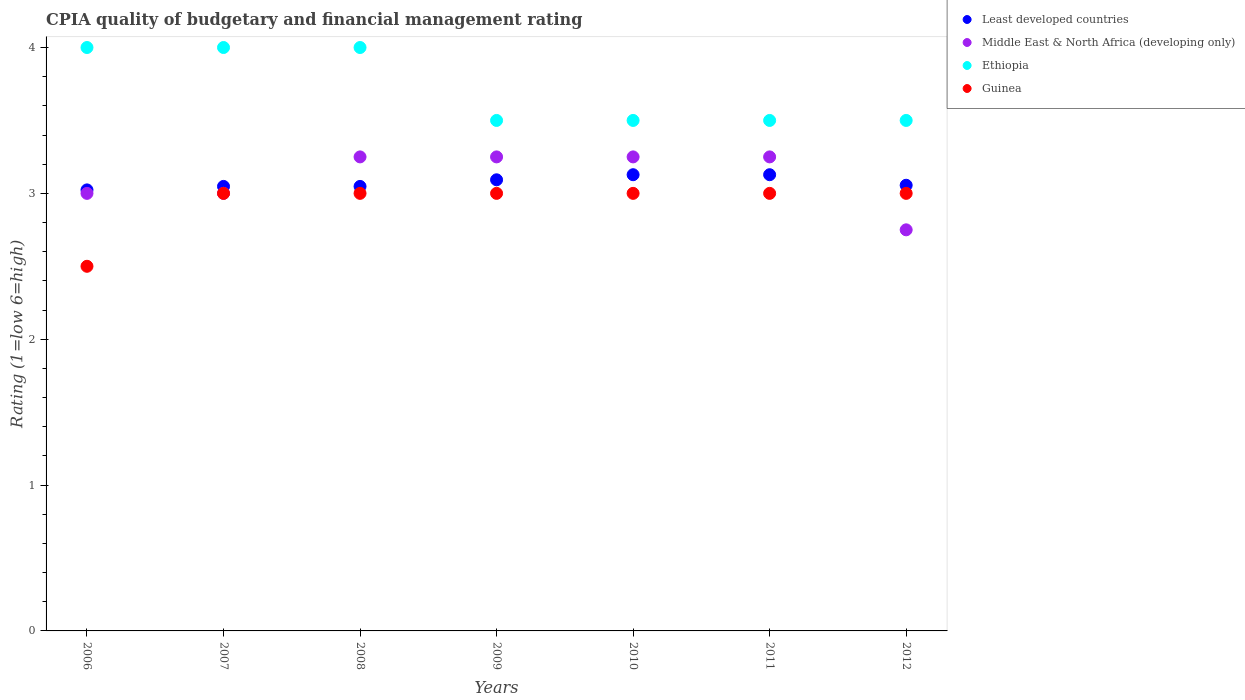Across all years, what is the maximum CPIA rating in Guinea?
Offer a terse response. 3. Across all years, what is the minimum CPIA rating in Middle East & North Africa (developing only)?
Offer a very short reply. 2.75. In which year was the CPIA rating in Ethiopia maximum?
Your answer should be compact. 2006. In which year was the CPIA rating in Guinea minimum?
Provide a succinct answer. 2006. What is the total CPIA rating in Least developed countries in the graph?
Provide a short and direct response. 21.52. What is the difference between the CPIA rating in Least developed countries in 2011 and the CPIA rating in Guinea in 2008?
Offer a terse response. 0.13. What is the average CPIA rating in Least developed countries per year?
Your response must be concise. 3.07. What is the ratio of the CPIA rating in Least developed countries in 2007 to that in 2010?
Offer a terse response. 0.97. Is the CPIA rating in Least developed countries in 2009 less than that in 2012?
Give a very brief answer. No. Is the difference between the CPIA rating in Ethiopia in 2006 and 2009 greater than the difference between the CPIA rating in Guinea in 2006 and 2009?
Give a very brief answer. Yes. What is the difference between the highest and the lowest CPIA rating in Guinea?
Ensure brevity in your answer.  0.5. Is it the case that in every year, the sum of the CPIA rating in Least developed countries and CPIA rating in Ethiopia  is greater than the sum of CPIA rating in Middle East & North Africa (developing only) and CPIA rating in Guinea?
Ensure brevity in your answer.  Yes. Is it the case that in every year, the sum of the CPIA rating in Guinea and CPIA rating in Ethiopia  is greater than the CPIA rating in Least developed countries?
Give a very brief answer. Yes. Does the CPIA rating in Guinea monotonically increase over the years?
Offer a very short reply. No. How many dotlines are there?
Your answer should be compact. 4. How many years are there in the graph?
Ensure brevity in your answer.  7. Are the values on the major ticks of Y-axis written in scientific E-notation?
Provide a succinct answer. No. Does the graph contain any zero values?
Provide a succinct answer. No. Does the graph contain grids?
Ensure brevity in your answer.  No. How are the legend labels stacked?
Offer a terse response. Vertical. What is the title of the graph?
Your answer should be very brief. CPIA quality of budgetary and financial management rating. What is the label or title of the X-axis?
Provide a succinct answer. Years. What is the Rating (1=low 6=high) of Least developed countries in 2006?
Ensure brevity in your answer.  3.02. What is the Rating (1=low 6=high) of Middle East & North Africa (developing only) in 2006?
Keep it short and to the point. 3. What is the Rating (1=low 6=high) of Least developed countries in 2007?
Your response must be concise. 3.05. What is the Rating (1=low 6=high) in Middle East & North Africa (developing only) in 2007?
Your response must be concise. 3. What is the Rating (1=low 6=high) of Ethiopia in 2007?
Give a very brief answer. 4. What is the Rating (1=low 6=high) in Guinea in 2007?
Your answer should be very brief. 3. What is the Rating (1=low 6=high) in Least developed countries in 2008?
Give a very brief answer. 3.05. What is the Rating (1=low 6=high) in Ethiopia in 2008?
Give a very brief answer. 4. What is the Rating (1=low 6=high) of Guinea in 2008?
Provide a short and direct response. 3. What is the Rating (1=low 6=high) of Least developed countries in 2009?
Your answer should be compact. 3.09. What is the Rating (1=low 6=high) in Middle East & North Africa (developing only) in 2009?
Offer a terse response. 3.25. What is the Rating (1=low 6=high) in Ethiopia in 2009?
Make the answer very short. 3.5. What is the Rating (1=low 6=high) of Guinea in 2009?
Give a very brief answer. 3. What is the Rating (1=low 6=high) in Least developed countries in 2010?
Give a very brief answer. 3.13. What is the Rating (1=low 6=high) of Ethiopia in 2010?
Provide a short and direct response. 3.5. What is the Rating (1=low 6=high) in Guinea in 2010?
Offer a terse response. 3. What is the Rating (1=low 6=high) in Least developed countries in 2011?
Make the answer very short. 3.13. What is the Rating (1=low 6=high) of Middle East & North Africa (developing only) in 2011?
Make the answer very short. 3.25. What is the Rating (1=low 6=high) of Least developed countries in 2012?
Your answer should be compact. 3.06. What is the Rating (1=low 6=high) of Middle East & North Africa (developing only) in 2012?
Offer a very short reply. 2.75. What is the Rating (1=low 6=high) in Guinea in 2012?
Your answer should be very brief. 3. Across all years, what is the maximum Rating (1=low 6=high) of Least developed countries?
Provide a succinct answer. 3.13. Across all years, what is the maximum Rating (1=low 6=high) in Ethiopia?
Provide a succinct answer. 4. Across all years, what is the maximum Rating (1=low 6=high) in Guinea?
Offer a terse response. 3. Across all years, what is the minimum Rating (1=low 6=high) of Least developed countries?
Your response must be concise. 3.02. Across all years, what is the minimum Rating (1=low 6=high) in Middle East & North Africa (developing only)?
Provide a succinct answer. 2.75. Across all years, what is the minimum Rating (1=low 6=high) of Guinea?
Provide a succinct answer. 2.5. What is the total Rating (1=low 6=high) of Least developed countries in the graph?
Offer a terse response. 21.52. What is the total Rating (1=low 6=high) of Middle East & North Africa (developing only) in the graph?
Offer a terse response. 21.75. What is the total Rating (1=low 6=high) in Guinea in the graph?
Ensure brevity in your answer.  20.5. What is the difference between the Rating (1=low 6=high) in Least developed countries in 2006 and that in 2007?
Your answer should be compact. -0.02. What is the difference between the Rating (1=low 6=high) in Guinea in 2006 and that in 2007?
Your answer should be very brief. -0.5. What is the difference between the Rating (1=low 6=high) in Least developed countries in 2006 and that in 2008?
Your answer should be very brief. -0.02. What is the difference between the Rating (1=low 6=high) of Middle East & North Africa (developing only) in 2006 and that in 2008?
Make the answer very short. -0.25. What is the difference between the Rating (1=low 6=high) in Least developed countries in 2006 and that in 2009?
Offer a terse response. -0.07. What is the difference between the Rating (1=low 6=high) in Ethiopia in 2006 and that in 2009?
Ensure brevity in your answer.  0.5. What is the difference between the Rating (1=low 6=high) of Least developed countries in 2006 and that in 2010?
Your answer should be compact. -0.1. What is the difference between the Rating (1=low 6=high) of Ethiopia in 2006 and that in 2010?
Make the answer very short. 0.5. What is the difference between the Rating (1=low 6=high) of Least developed countries in 2006 and that in 2011?
Provide a succinct answer. -0.1. What is the difference between the Rating (1=low 6=high) of Middle East & North Africa (developing only) in 2006 and that in 2011?
Ensure brevity in your answer.  -0.25. What is the difference between the Rating (1=low 6=high) of Ethiopia in 2006 and that in 2011?
Provide a succinct answer. 0.5. What is the difference between the Rating (1=low 6=high) of Guinea in 2006 and that in 2011?
Ensure brevity in your answer.  -0.5. What is the difference between the Rating (1=low 6=high) of Least developed countries in 2006 and that in 2012?
Offer a terse response. -0.03. What is the difference between the Rating (1=low 6=high) of Ethiopia in 2006 and that in 2012?
Offer a terse response. 0.5. What is the difference between the Rating (1=low 6=high) in Guinea in 2006 and that in 2012?
Your response must be concise. -0.5. What is the difference between the Rating (1=low 6=high) of Least developed countries in 2007 and that in 2008?
Provide a short and direct response. 0. What is the difference between the Rating (1=low 6=high) in Least developed countries in 2007 and that in 2009?
Keep it short and to the point. -0.05. What is the difference between the Rating (1=low 6=high) of Ethiopia in 2007 and that in 2009?
Make the answer very short. 0.5. What is the difference between the Rating (1=low 6=high) in Guinea in 2007 and that in 2009?
Your answer should be very brief. 0. What is the difference between the Rating (1=low 6=high) in Least developed countries in 2007 and that in 2010?
Offer a terse response. -0.08. What is the difference between the Rating (1=low 6=high) in Middle East & North Africa (developing only) in 2007 and that in 2010?
Your answer should be very brief. -0.25. What is the difference between the Rating (1=low 6=high) of Least developed countries in 2007 and that in 2011?
Your answer should be very brief. -0.08. What is the difference between the Rating (1=low 6=high) in Middle East & North Africa (developing only) in 2007 and that in 2011?
Provide a short and direct response. -0.25. What is the difference between the Rating (1=low 6=high) in Ethiopia in 2007 and that in 2011?
Provide a short and direct response. 0.5. What is the difference between the Rating (1=low 6=high) in Least developed countries in 2007 and that in 2012?
Your answer should be very brief. -0.01. What is the difference between the Rating (1=low 6=high) of Guinea in 2007 and that in 2012?
Your answer should be compact. 0. What is the difference between the Rating (1=low 6=high) in Least developed countries in 2008 and that in 2009?
Keep it short and to the point. -0.05. What is the difference between the Rating (1=low 6=high) in Least developed countries in 2008 and that in 2010?
Ensure brevity in your answer.  -0.08. What is the difference between the Rating (1=low 6=high) in Guinea in 2008 and that in 2010?
Your response must be concise. 0. What is the difference between the Rating (1=low 6=high) in Least developed countries in 2008 and that in 2011?
Make the answer very short. -0.08. What is the difference between the Rating (1=low 6=high) of Guinea in 2008 and that in 2011?
Provide a short and direct response. 0. What is the difference between the Rating (1=low 6=high) in Least developed countries in 2008 and that in 2012?
Offer a very short reply. -0.01. What is the difference between the Rating (1=low 6=high) of Ethiopia in 2008 and that in 2012?
Your answer should be compact. 0.5. What is the difference between the Rating (1=low 6=high) in Least developed countries in 2009 and that in 2010?
Keep it short and to the point. -0.03. What is the difference between the Rating (1=low 6=high) in Least developed countries in 2009 and that in 2011?
Ensure brevity in your answer.  -0.03. What is the difference between the Rating (1=low 6=high) of Middle East & North Africa (developing only) in 2009 and that in 2011?
Keep it short and to the point. 0. What is the difference between the Rating (1=low 6=high) of Least developed countries in 2009 and that in 2012?
Offer a very short reply. 0.04. What is the difference between the Rating (1=low 6=high) in Least developed countries in 2010 and that in 2011?
Offer a terse response. 0. What is the difference between the Rating (1=low 6=high) of Ethiopia in 2010 and that in 2011?
Make the answer very short. 0. What is the difference between the Rating (1=low 6=high) in Least developed countries in 2010 and that in 2012?
Your answer should be very brief. 0.07. What is the difference between the Rating (1=low 6=high) in Ethiopia in 2010 and that in 2012?
Make the answer very short. 0. What is the difference between the Rating (1=low 6=high) in Guinea in 2010 and that in 2012?
Provide a succinct answer. 0. What is the difference between the Rating (1=low 6=high) in Least developed countries in 2011 and that in 2012?
Your answer should be compact. 0.07. What is the difference between the Rating (1=low 6=high) in Guinea in 2011 and that in 2012?
Offer a very short reply. 0. What is the difference between the Rating (1=low 6=high) of Least developed countries in 2006 and the Rating (1=low 6=high) of Middle East & North Africa (developing only) in 2007?
Your answer should be very brief. 0.02. What is the difference between the Rating (1=low 6=high) in Least developed countries in 2006 and the Rating (1=low 6=high) in Ethiopia in 2007?
Provide a short and direct response. -0.98. What is the difference between the Rating (1=low 6=high) in Least developed countries in 2006 and the Rating (1=low 6=high) in Guinea in 2007?
Your answer should be very brief. 0.02. What is the difference between the Rating (1=low 6=high) in Middle East & North Africa (developing only) in 2006 and the Rating (1=low 6=high) in Guinea in 2007?
Give a very brief answer. 0. What is the difference between the Rating (1=low 6=high) of Least developed countries in 2006 and the Rating (1=low 6=high) of Middle East & North Africa (developing only) in 2008?
Keep it short and to the point. -0.23. What is the difference between the Rating (1=low 6=high) in Least developed countries in 2006 and the Rating (1=low 6=high) in Ethiopia in 2008?
Offer a terse response. -0.98. What is the difference between the Rating (1=low 6=high) of Least developed countries in 2006 and the Rating (1=low 6=high) of Guinea in 2008?
Give a very brief answer. 0.02. What is the difference between the Rating (1=low 6=high) in Middle East & North Africa (developing only) in 2006 and the Rating (1=low 6=high) in Guinea in 2008?
Offer a terse response. 0. What is the difference between the Rating (1=low 6=high) of Ethiopia in 2006 and the Rating (1=low 6=high) of Guinea in 2008?
Ensure brevity in your answer.  1. What is the difference between the Rating (1=low 6=high) in Least developed countries in 2006 and the Rating (1=low 6=high) in Middle East & North Africa (developing only) in 2009?
Give a very brief answer. -0.23. What is the difference between the Rating (1=low 6=high) of Least developed countries in 2006 and the Rating (1=low 6=high) of Ethiopia in 2009?
Keep it short and to the point. -0.48. What is the difference between the Rating (1=low 6=high) of Least developed countries in 2006 and the Rating (1=low 6=high) of Guinea in 2009?
Your response must be concise. 0.02. What is the difference between the Rating (1=low 6=high) in Middle East & North Africa (developing only) in 2006 and the Rating (1=low 6=high) in Ethiopia in 2009?
Your answer should be compact. -0.5. What is the difference between the Rating (1=low 6=high) in Middle East & North Africa (developing only) in 2006 and the Rating (1=low 6=high) in Guinea in 2009?
Provide a succinct answer. 0. What is the difference between the Rating (1=low 6=high) of Least developed countries in 2006 and the Rating (1=low 6=high) of Middle East & North Africa (developing only) in 2010?
Provide a succinct answer. -0.23. What is the difference between the Rating (1=low 6=high) in Least developed countries in 2006 and the Rating (1=low 6=high) in Ethiopia in 2010?
Provide a succinct answer. -0.48. What is the difference between the Rating (1=low 6=high) of Least developed countries in 2006 and the Rating (1=low 6=high) of Guinea in 2010?
Provide a succinct answer. 0.02. What is the difference between the Rating (1=low 6=high) of Middle East & North Africa (developing only) in 2006 and the Rating (1=low 6=high) of Guinea in 2010?
Your response must be concise. 0. What is the difference between the Rating (1=low 6=high) in Least developed countries in 2006 and the Rating (1=low 6=high) in Middle East & North Africa (developing only) in 2011?
Make the answer very short. -0.23. What is the difference between the Rating (1=low 6=high) of Least developed countries in 2006 and the Rating (1=low 6=high) of Ethiopia in 2011?
Make the answer very short. -0.48. What is the difference between the Rating (1=low 6=high) in Least developed countries in 2006 and the Rating (1=low 6=high) in Guinea in 2011?
Your response must be concise. 0.02. What is the difference between the Rating (1=low 6=high) of Least developed countries in 2006 and the Rating (1=low 6=high) of Middle East & North Africa (developing only) in 2012?
Your answer should be very brief. 0.27. What is the difference between the Rating (1=low 6=high) of Least developed countries in 2006 and the Rating (1=low 6=high) of Ethiopia in 2012?
Ensure brevity in your answer.  -0.48. What is the difference between the Rating (1=low 6=high) of Least developed countries in 2006 and the Rating (1=low 6=high) of Guinea in 2012?
Make the answer very short. 0.02. What is the difference between the Rating (1=low 6=high) of Middle East & North Africa (developing only) in 2006 and the Rating (1=low 6=high) of Guinea in 2012?
Your response must be concise. 0. What is the difference between the Rating (1=low 6=high) in Least developed countries in 2007 and the Rating (1=low 6=high) in Middle East & North Africa (developing only) in 2008?
Your response must be concise. -0.2. What is the difference between the Rating (1=low 6=high) of Least developed countries in 2007 and the Rating (1=low 6=high) of Ethiopia in 2008?
Your answer should be compact. -0.95. What is the difference between the Rating (1=low 6=high) in Least developed countries in 2007 and the Rating (1=low 6=high) in Guinea in 2008?
Ensure brevity in your answer.  0.05. What is the difference between the Rating (1=low 6=high) in Middle East & North Africa (developing only) in 2007 and the Rating (1=low 6=high) in Guinea in 2008?
Make the answer very short. 0. What is the difference between the Rating (1=low 6=high) in Ethiopia in 2007 and the Rating (1=low 6=high) in Guinea in 2008?
Offer a terse response. 1. What is the difference between the Rating (1=low 6=high) in Least developed countries in 2007 and the Rating (1=low 6=high) in Middle East & North Africa (developing only) in 2009?
Provide a short and direct response. -0.2. What is the difference between the Rating (1=low 6=high) of Least developed countries in 2007 and the Rating (1=low 6=high) of Ethiopia in 2009?
Give a very brief answer. -0.45. What is the difference between the Rating (1=low 6=high) in Least developed countries in 2007 and the Rating (1=low 6=high) in Guinea in 2009?
Offer a terse response. 0.05. What is the difference between the Rating (1=low 6=high) of Ethiopia in 2007 and the Rating (1=low 6=high) of Guinea in 2009?
Keep it short and to the point. 1. What is the difference between the Rating (1=low 6=high) of Least developed countries in 2007 and the Rating (1=low 6=high) of Middle East & North Africa (developing only) in 2010?
Provide a short and direct response. -0.2. What is the difference between the Rating (1=low 6=high) in Least developed countries in 2007 and the Rating (1=low 6=high) in Ethiopia in 2010?
Ensure brevity in your answer.  -0.45. What is the difference between the Rating (1=low 6=high) in Least developed countries in 2007 and the Rating (1=low 6=high) in Guinea in 2010?
Your answer should be very brief. 0.05. What is the difference between the Rating (1=low 6=high) of Middle East & North Africa (developing only) in 2007 and the Rating (1=low 6=high) of Ethiopia in 2010?
Keep it short and to the point. -0.5. What is the difference between the Rating (1=low 6=high) in Middle East & North Africa (developing only) in 2007 and the Rating (1=low 6=high) in Guinea in 2010?
Make the answer very short. 0. What is the difference between the Rating (1=low 6=high) of Least developed countries in 2007 and the Rating (1=low 6=high) of Middle East & North Africa (developing only) in 2011?
Offer a terse response. -0.2. What is the difference between the Rating (1=low 6=high) in Least developed countries in 2007 and the Rating (1=low 6=high) in Ethiopia in 2011?
Provide a succinct answer. -0.45. What is the difference between the Rating (1=low 6=high) of Least developed countries in 2007 and the Rating (1=low 6=high) of Guinea in 2011?
Offer a terse response. 0.05. What is the difference between the Rating (1=low 6=high) in Middle East & North Africa (developing only) in 2007 and the Rating (1=low 6=high) in Ethiopia in 2011?
Offer a very short reply. -0.5. What is the difference between the Rating (1=low 6=high) of Ethiopia in 2007 and the Rating (1=low 6=high) of Guinea in 2011?
Provide a short and direct response. 1. What is the difference between the Rating (1=low 6=high) of Least developed countries in 2007 and the Rating (1=low 6=high) of Middle East & North Africa (developing only) in 2012?
Provide a short and direct response. 0.3. What is the difference between the Rating (1=low 6=high) of Least developed countries in 2007 and the Rating (1=low 6=high) of Ethiopia in 2012?
Provide a short and direct response. -0.45. What is the difference between the Rating (1=low 6=high) in Least developed countries in 2007 and the Rating (1=low 6=high) in Guinea in 2012?
Your answer should be compact. 0.05. What is the difference between the Rating (1=low 6=high) in Middle East & North Africa (developing only) in 2007 and the Rating (1=low 6=high) in Ethiopia in 2012?
Keep it short and to the point. -0.5. What is the difference between the Rating (1=low 6=high) of Ethiopia in 2007 and the Rating (1=low 6=high) of Guinea in 2012?
Offer a very short reply. 1. What is the difference between the Rating (1=low 6=high) in Least developed countries in 2008 and the Rating (1=low 6=high) in Middle East & North Africa (developing only) in 2009?
Give a very brief answer. -0.2. What is the difference between the Rating (1=low 6=high) in Least developed countries in 2008 and the Rating (1=low 6=high) in Ethiopia in 2009?
Provide a succinct answer. -0.45. What is the difference between the Rating (1=low 6=high) in Least developed countries in 2008 and the Rating (1=low 6=high) in Guinea in 2009?
Provide a short and direct response. 0.05. What is the difference between the Rating (1=low 6=high) of Middle East & North Africa (developing only) in 2008 and the Rating (1=low 6=high) of Guinea in 2009?
Give a very brief answer. 0.25. What is the difference between the Rating (1=low 6=high) of Least developed countries in 2008 and the Rating (1=low 6=high) of Middle East & North Africa (developing only) in 2010?
Offer a terse response. -0.2. What is the difference between the Rating (1=low 6=high) in Least developed countries in 2008 and the Rating (1=low 6=high) in Ethiopia in 2010?
Provide a short and direct response. -0.45. What is the difference between the Rating (1=low 6=high) of Least developed countries in 2008 and the Rating (1=low 6=high) of Guinea in 2010?
Provide a succinct answer. 0.05. What is the difference between the Rating (1=low 6=high) of Middle East & North Africa (developing only) in 2008 and the Rating (1=low 6=high) of Ethiopia in 2010?
Offer a terse response. -0.25. What is the difference between the Rating (1=low 6=high) in Middle East & North Africa (developing only) in 2008 and the Rating (1=low 6=high) in Guinea in 2010?
Offer a very short reply. 0.25. What is the difference between the Rating (1=low 6=high) in Least developed countries in 2008 and the Rating (1=low 6=high) in Middle East & North Africa (developing only) in 2011?
Your response must be concise. -0.2. What is the difference between the Rating (1=low 6=high) of Least developed countries in 2008 and the Rating (1=low 6=high) of Ethiopia in 2011?
Ensure brevity in your answer.  -0.45. What is the difference between the Rating (1=low 6=high) of Least developed countries in 2008 and the Rating (1=low 6=high) of Guinea in 2011?
Your response must be concise. 0.05. What is the difference between the Rating (1=low 6=high) in Middle East & North Africa (developing only) in 2008 and the Rating (1=low 6=high) in Ethiopia in 2011?
Offer a very short reply. -0.25. What is the difference between the Rating (1=low 6=high) of Ethiopia in 2008 and the Rating (1=low 6=high) of Guinea in 2011?
Give a very brief answer. 1. What is the difference between the Rating (1=low 6=high) of Least developed countries in 2008 and the Rating (1=low 6=high) of Middle East & North Africa (developing only) in 2012?
Your answer should be compact. 0.3. What is the difference between the Rating (1=low 6=high) of Least developed countries in 2008 and the Rating (1=low 6=high) of Ethiopia in 2012?
Ensure brevity in your answer.  -0.45. What is the difference between the Rating (1=low 6=high) of Least developed countries in 2008 and the Rating (1=low 6=high) of Guinea in 2012?
Provide a short and direct response. 0.05. What is the difference between the Rating (1=low 6=high) in Middle East & North Africa (developing only) in 2008 and the Rating (1=low 6=high) in Guinea in 2012?
Make the answer very short. 0.25. What is the difference between the Rating (1=low 6=high) in Least developed countries in 2009 and the Rating (1=low 6=high) in Middle East & North Africa (developing only) in 2010?
Your answer should be very brief. -0.16. What is the difference between the Rating (1=low 6=high) in Least developed countries in 2009 and the Rating (1=low 6=high) in Ethiopia in 2010?
Offer a very short reply. -0.41. What is the difference between the Rating (1=low 6=high) of Least developed countries in 2009 and the Rating (1=low 6=high) of Guinea in 2010?
Your answer should be compact. 0.09. What is the difference between the Rating (1=low 6=high) in Middle East & North Africa (developing only) in 2009 and the Rating (1=low 6=high) in Ethiopia in 2010?
Your answer should be very brief. -0.25. What is the difference between the Rating (1=low 6=high) of Middle East & North Africa (developing only) in 2009 and the Rating (1=low 6=high) of Guinea in 2010?
Provide a succinct answer. 0.25. What is the difference between the Rating (1=low 6=high) in Ethiopia in 2009 and the Rating (1=low 6=high) in Guinea in 2010?
Provide a short and direct response. 0.5. What is the difference between the Rating (1=low 6=high) in Least developed countries in 2009 and the Rating (1=low 6=high) in Middle East & North Africa (developing only) in 2011?
Ensure brevity in your answer.  -0.16. What is the difference between the Rating (1=low 6=high) in Least developed countries in 2009 and the Rating (1=low 6=high) in Ethiopia in 2011?
Ensure brevity in your answer.  -0.41. What is the difference between the Rating (1=low 6=high) of Least developed countries in 2009 and the Rating (1=low 6=high) of Guinea in 2011?
Keep it short and to the point. 0.09. What is the difference between the Rating (1=low 6=high) in Middle East & North Africa (developing only) in 2009 and the Rating (1=low 6=high) in Guinea in 2011?
Your answer should be very brief. 0.25. What is the difference between the Rating (1=low 6=high) in Least developed countries in 2009 and the Rating (1=low 6=high) in Middle East & North Africa (developing only) in 2012?
Offer a very short reply. 0.34. What is the difference between the Rating (1=low 6=high) of Least developed countries in 2009 and the Rating (1=low 6=high) of Ethiopia in 2012?
Provide a short and direct response. -0.41. What is the difference between the Rating (1=low 6=high) of Least developed countries in 2009 and the Rating (1=low 6=high) of Guinea in 2012?
Keep it short and to the point. 0.09. What is the difference between the Rating (1=low 6=high) in Middle East & North Africa (developing only) in 2009 and the Rating (1=low 6=high) in Ethiopia in 2012?
Your answer should be very brief. -0.25. What is the difference between the Rating (1=low 6=high) in Middle East & North Africa (developing only) in 2009 and the Rating (1=low 6=high) in Guinea in 2012?
Your answer should be compact. 0.25. What is the difference between the Rating (1=low 6=high) of Least developed countries in 2010 and the Rating (1=low 6=high) of Middle East & North Africa (developing only) in 2011?
Offer a terse response. -0.12. What is the difference between the Rating (1=low 6=high) in Least developed countries in 2010 and the Rating (1=low 6=high) in Ethiopia in 2011?
Your response must be concise. -0.37. What is the difference between the Rating (1=low 6=high) in Least developed countries in 2010 and the Rating (1=low 6=high) in Guinea in 2011?
Provide a succinct answer. 0.13. What is the difference between the Rating (1=low 6=high) of Middle East & North Africa (developing only) in 2010 and the Rating (1=low 6=high) of Ethiopia in 2011?
Provide a short and direct response. -0.25. What is the difference between the Rating (1=low 6=high) of Middle East & North Africa (developing only) in 2010 and the Rating (1=low 6=high) of Guinea in 2011?
Offer a terse response. 0.25. What is the difference between the Rating (1=low 6=high) of Least developed countries in 2010 and the Rating (1=low 6=high) of Middle East & North Africa (developing only) in 2012?
Give a very brief answer. 0.38. What is the difference between the Rating (1=low 6=high) in Least developed countries in 2010 and the Rating (1=low 6=high) in Ethiopia in 2012?
Keep it short and to the point. -0.37. What is the difference between the Rating (1=low 6=high) of Least developed countries in 2010 and the Rating (1=low 6=high) of Guinea in 2012?
Offer a terse response. 0.13. What is the difference between the Rating (1=low 6=high) in Middle East & North Africa (developing only) in 2010 and the Rating (1=low 6=high) in Ethiopia in 2012?
Offer a terse response. -0.25. What is the difference between the Rating (1=low 6=high) of Middle East & North Africa (developing only) in 2010 and the Rating (1=low 6=high) of Guinea in 2012?
Make the answer very short. 0.25. What is the difference between the Rating (1=low 6=high) in Least developed countries in 2011 and the Rating (1=low 6=high) in Middle East & North Africa (developing only) in 2012?
Give a very brief answer. 0.38. What is the difference between the Rating (1=low 6=high) of Least developed countries in 2011 and the Rating (1=low 6=high) of Ethiopia in 2012?
Offer a terse response. -0.37. What is the difference between the Rating (1=low 6=high) of Least developed countries in 2011 and the Rating (1=low 6=high) of Guinea in 2012?
Provide a short and direct response. 0.13. What is the difference between the Rating (1=low 6=high) of Middle East & North Africa (developing only) in 2011 and the Rating (1=low 6=high) of Ethiopia in 2012?
Ensure brevity in your answer.  -0.25. What is the difference between the Rating (1=low 6=high) in Ethiopia in 2011 and the Rating (1=low 6=high) in Guinea in 2012?
Keep it short and to the point. 0.5. What is the average Rating (1=low 6=high) in Least developed countries per year?
Provide a succinct answer. 3.07. What is the average Rating (1=low 6=high) of Middle East & North Africa (developing only) per year?
Provide a short and direct response. 3.11. What is the average Rating (1=low 6=high) of Ethiopia per year?
Provide a succinct answer. 3.71. What is the average Rating (1=low 6=high) of Guinea per year?
Offer a very short reply. 2.93. In the year 2006, what is the difference between the Rating (1=low 6=high) in Least developed countries and Rating (1=low 6=high) in Middle East & North Africa (developing only)?
Keep it short and to the point. 0.02. In the year 2006, what is the difference between the Rating (1=low 6=high) in Least developed countries and Rating (1=low 6=high) in Ethiopia?
Give a very brief answer. -0.98. In the year 2006, what is the difference between the Rating (1=low 6=high) in Least developed countries and Rating (1=low 6=high) in Guinea?
Ensure brevity in your answer.  0.52. In the year 2006, what is the difference between the Rating (1=low 6=high) of Middle East & North Africa (developing only) and Rating (1=low 6=high) of Guinea?
Offer a terse response. 0.5. In the year 2007, what is the difference between the Rating (1=low 6=high) of Least developed countries and Rating (1=low 6=high) of Middle East & North Africa (developing only)?
Provide a succinct answer. 0.05. In the year 2007, what is the difference between the Rating (1=low 6=high) of Least developed countries and Rating (1=low 6=high) of Ethiopia?
Give a very brief answer. -0.95. In the year 2007, what is the difference between the Rating (1=low 6=high) in Least developed countries and Rating (1=low 6=high) in Guinea?
Provide a short and direct response. 0.05. In the year 2007, what is the difference between the Rating (1=low 6=high) of Ethiopia and Rating (1=low 6=high) of Guinea?
Your response must be concise. 1. In the year 2008, what is the difference between the Rating (1=low 6=high) in Least developed countries and Rating (1=low 6=high) in Middle East & North Africa (developing only)?
Keep it short and to the point. -0.2. In the year 2008, what is the difference between the Rating (1=low 6=high) of Least developed countries and Rating (1=low 6=high) of Ethiopia?
Your answer should be compact. -0.95. In the year 2008, what is the difference between the Rating (1=low 6=high) in Least developed countries and Rating (1=low 6=high) in Guinea?
Offer a very short reply. 0.05. In the year 2008, what is the difference between the Rating (1=low 6=high) of Middle East & North Africa (developing only) and Rating (1=low 6=high) of Ethiopia?
Your answer should be very brief. -0.75. In the year 2008, what is the difference between the Rating (1=low 6=high) of Ethiopia and Rating (1=low 6=high) of Guinea?
Provide a succinct answer. 1. In the year 2009, what is the difference between the Rating (1=low 6=high) of Least developed countries and Rating (1=low 6=high) of Middle East & North Africa (developing only)?
Ensure brevity in your answer.  -0.16. In the year 2009, what is the difference between the Rating (1=low 6=high) in Least developed countries and Rating (1=low 6=high) in Ethiopia?
Provide a short and direct response. -0.41. In the year 2009, what is the difference between the Rating (1=low 6=high) in Least developed countries and Rating (1=low 6=high) in Guinea?
Your response must be concise. 0.09. In the year 2009, what is the difference between the Rating (1=low 6=high) of Middle East & North Africa (developing only) and Rating (1=low 6=high) of Ethiopia?
Ensure brevity in your answer.  -0.25. In the year 2010, what is the difference between the Rating (1=low 6=high) in Least developed countries and Rating (1=low 6=high) in Middle East & North Africa (developing only)?
Your answer should be compact. -0.12. In the year 2010, what is the difference between the Rating (1=low 6=high) of Least developed countries and Rating (1=low 6=high) of Ethiopia?
Make the answer very short. -0.37. In the year 2010, what is the difference between the Rating (1=low 6=high) of Least developed countries and Rating (1=low 6=high) of Guinea?
Your answer should be very brief. 0.13. In the year 2011, what is the difference between the Rating (1=low 6=high) in Least developed countries and Rating (1=low 6=high) in Middle East & North Africa (developing only)?
Give a very brief answer. -0.12. In the year 2011, what is the difference between the Rating (1=low 6=high) in Least developed countries and Rating (1=low 6=high) in Ethiopia?
Your answer should be compact. -0.37. In the year 2011, what is the difference between the Rating (1=low 6=high) in Least developed countries and Rating (1=low 6=high) in Guinea?
Ensure brevity in your answer.  0.13. In the year 2011, what is the difference between the Rating (1=low 6=high) in Middle East & North Africa (developing only) and Rating (1=low 6=high) in Ethiopia?
Your answer should be very brief. -0.25. In the year 2011, what is the difference between the Rating (1=low 6=high) of Ethiopia and Rating (1=low 6=high) of Guinea?
Provide a short and direct response. 0.5. In the year 2012, what is the difference between the Rating (1=low 6=high) in Least developed countries and Rating (1=low 6=high) in Middle East & North Africa (developing only)?
Offer a terse response. 0.31. In the year 2012, what is the difference between the Rating (1=low 6=high) in Least developed countries and Rating (1=low 6=high) in Ethiopia?
Provide a succinct answer. -0.44. In the year 2012, what is the difference between the Rating (1=low 6=high) of Least developed countries and Rating (1=low 6=high) of Guinea?
Provide a succinct answer. 0.06. In the year 2012, what is the difference between the Rating (1=low 6=high) in Middle East & North Africa (developing only) and Rating (1=low 6=high) in Ethiopia?
Make the answer very short. -0.75. In the year 2012, what is the difference between the Rating (1=low 6=high) of Middle East & North Africa (developing only) and Rating (1=low 6=high) of Guinea?
Provide a short and direct response. -0.25. In the year 2012, what is the difference between the Rating (1=low 6=high) of Ethiopia and Rating (1=low 6=high) of Guinea?
Ensure brevity in your answer.  0.5. What is the ratio of the Rating (1=low 6=high) in Least developed countries in 2006 to that in 2007?
Your response must be concise. 0.99. What is the ratio of the Rating (1=low 6=high) in Ethiopia in 2006 to that in 2007?
Keep it short and to the point. 1. What is the ratio of the Rating (1=low 6=high) of Guinea in 2006 to that in 2007?
Your response must be concise. 0.83. What is the ratio of the Rating (1=low 6=high) in Least developed countries in 2006 to that in 2008?
Keep it short and to the point. 0.99. What is the ratio of the Rating (1=low 6=high) in Ethiopia in 2006 to that in 2008?
Provide a short and direct response. 1. What is the ratio of the Rating (1=low 6=high) in Guinea in 2006 to that in 2008?
Keep it short and to the point. 0.83. What is the ratio of the Rating (1=low 6=high) in Least developed countries in 2006 to that in 2009?
Provide a succinct answer. 0.98. What is the ratio of the Rating (1=low 6=high) of Middle East & North Africa (developing only) in 2006 to that in 2009?
Your answer should be very brief. 0.92. What is the ratio of the Rating (1=low 6=high) of Ethiopia in 2006 to that in 2009?
Your answer should be very brief. 1.14. What is the ratio of the Rating (1=low 6=high) in Least developed countries in 2006 to that in 2010?
Offer a very short reply. 0.97. What is the ratio of the Rating (1=low 6=high) of Guinea in 2006 to that in 2010?
Offer a terse response. 0.83. What is the ratio of the Rating (1=low 6=high) of Least developed countries in 2006 to that in 2011?
Your answer should be very brief. 0.97. What is the ratio of the Rating (1=low 6=high) of Middle East & North Africa (developing only) in 2006 to that in 2011?
Provide a short and direct response. 0.92. What is the ratio of the Rating (1=low 6=high) of Least developed countries in 2006 to that in 2012?
Give a very brief answer. 0.99. What is the ratio of the Rating (1=low 6=high) in Guinea in 2007 to that in 2008?
Your answer should be compact. 1. What is the ratio of the Rating (1=low 6=high) in Guinea in 2007 to that in 2009?
Give a very brief answer. 1. What is the ratio of the Rating (1=low 6=high) in Least developed countries in 2007 to that in 2010?
Your answer should be very brief. 0.97. What is the ratio of the Rating (1=low 6=high) in Middle East & North Africa (developing only) in 2007 to that in 2010?
Your response must be concise. 0.92. What is the ratio of the Rating (1=low 6=high) in Guinea in 2007 to that in 2010?
Keep it short and to the point. 1. What is the ratio of the Rating (1=low 6=high) of Least developed countries in 2007 to that in 2011?
Make the answer very short. 0.97. What is the ratio of the Rating (1=low 6=high) in Middle East & North Africa (developing only) in 2007 to that in 2011?
Keep it short and to the point. 0.92. What is the ratio of the Rating (1=low 6=high) of Guinea in 2007 to that in 2011?
Keep it short and to the point. 1. What is the ratio of the Rating (1=low 6=high) in Ethiopia in 2007 to that in 2012?
Offer a very short reply. 1.14. What is the ratio of the Rating (1=low 6=high) of Guinea in 2007 to that in 2012?
Keep it short and to the point. 1. What is the ratio of the Rating (1=low 6=high) of Guinea in 2008 to that in 2009?
Ensure brevity in your answer.  1. What is the ratio of the Rating (1=low 6=high) of Least developed countries in 2008 to that in 2010?
Ensure brevity in your answer.  0.97. What is the ratio of the Rating (1=low 6=high) in Middle East & North Africa (developing only) in 2008 to that in 2010?
Offer a terse response. 1. What is the ratio of the Rating (1=low 6=high) in Least developed countries in 2008 to that in 2011?
Keep it short and to the point. 0.97. What is the ratio of the Rating (1=low 6=high) in Guinea in 2008 to that in 2011?
Provide a short and direct response. 1. What is the ratio of the Rating (1=low 6=high) of Least developed countries in 2008 to that in 2012?
Give a very brief answer. 1. What is the ratio of the Rating (1=low 6=high) in Middle East & North Africa (developing only) in 2008 to that in 2012?
Provide a succinct answer. 1.18. What is the ratio of the Rating (1=low 6=high) in Ethiopia in 2008 to that in 2012?
Ensure brevity in your answer.  1.14. What is the ratio of the Rating (1=low 6=high) of Least developed countries in 2009 to that in 2010?
Your response must be concise. 0.99. What is the ratio of the Rating (1=low 6=high) of Ethiopia in 2009 to that in 2010?
Give a very brief answer. 1. What is the ratio of the Rating (1=low 6=high) of Guinea in 2009 to that in 2010?
Your answer should be compact. 1. What is the ratio of the Rating (1=low 6=high) of Least developed countries in 2009 to that in 2011?
Offer a very short reply. 0.99. What is the ratio of the Rating (1=low 6=high) of Least developed countries in 2009 to that in 2012?
Provide a short and direct response. 1.01. What is the ratio of the Rating (1=low 6=high) of Middle East & North Africa (developing only) in 2009 to that in 2012?
Your answer should be very brief. 1.18. What is the ratio of the Rating (1=low 6=high) of Ethiopia in 2009 to that in 2012?
Offer a terse response. 1. What is the ratio of the Rating (1=low 6=high) of Guinea in 2009 to that in 2012?
Provide a succinct answer. 1. What is the ratio of the Rating (1=low 6=high) of Least developed countries in 2010 to that in 2011?
Give a very brief answer. 1. What is the ratio of the Rating (1=low 6=high) in Middle East & North Africa (developing only) in 2010 to that in 2011?
Give a very brief answer. 1. What is the ratio of the Rating (1=low 6=high) of Least developed countries in 2010 to that in 2012?
Give a very brief answer. 1.02. What is the ratio of the Rating (1=low 6=high) of Middle East & North Africa (developing only) in 2010 to that in 2012?
Keep it short and to the point. 1.18. What is the ratio of the Rating (1=low 6=high) of Ethiopia in 2010 to that in 2012?
Keep it short and to the point. 1. What is the ratio of the Rating (1=low 6=high) in Least developed countries in 2011 to that in 2012?
Your answer should be compact. 1.02. What is the ratio of the Rating (1=low 6=high) of Middle East & North Africa (developing only) in 2011 to that in 2012?
Your answer should be very brief. 1.18. What is the ratio of the Rating (1=low 6=high) of Ethiopia in 2011 to that in 2012?
Offer a very short reply. 1. What is the ratio of the Rating (1=low 6=high) in Guinea in 2011 to that in 2012?
Your response must be concise. 1. What is the difference between the highest and the second highest Rating (1=low 6=high) in Middle East & North Africa (developing only)?
Offer a terse response. 0. What is the difference between the highest and the lowest Rating (1=low 6=high) in Least developed countries?
Your answer should be compact. 0.1. What is the difference between the highest and the lowest Rating (1=low 6=high) of Ethiopia?
Give a very brief answer. 0.5. 